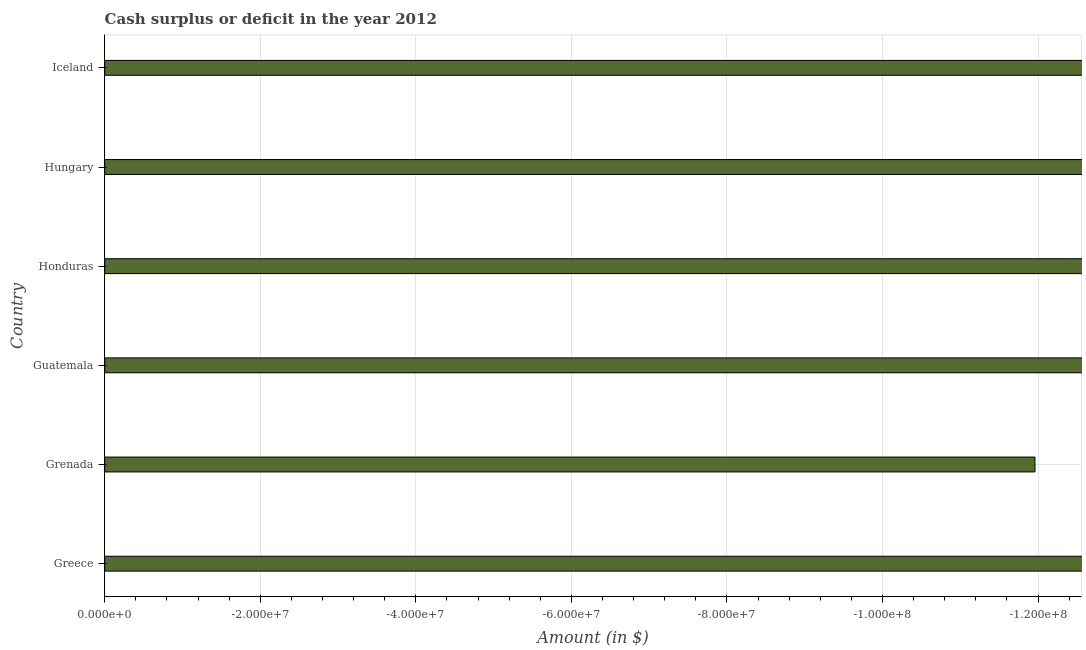Does the graph contain any zero values?
Offer a very short reply. Yes. What is the title of the graph?
Give a very brief answer. Cash surplus or deficit in the year 2012. What is the label or title of the X-axis?
Offer a very short reply. Amount (in $). What is the average cash surplus or deficit per country?
Your answer should be compact. 0. What is the median cash surplus or deficit?
Provide a short and direct response. 0. In how many countries, is the cash surplus or deficit greater than -104000000 $?
Provide a short and direct response. 0. Are all the bars in the graph horizontal?
Your answer should be compact. Yes. How many countries are there in the graph?
Offer a very short reply. 6. What is the difference between two consecutive major ticks on the X-axis?
Offer a terse response. 2.00e+07. What is the Amount (in $) in Guatemala?
Keep it short and to the point. 0. What is the Amount (in $) of Honduras?
Offer a terse response. 0. What is the Amount (in $) in Iceland?
Make the answer very short. 0. 